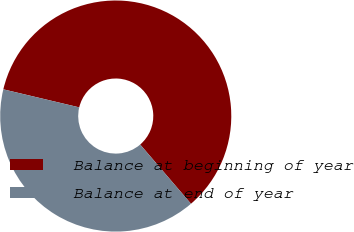Convert chart to OTSL. <chart><loc_0><loc_0><loc_500><loc_500><pie_chart><fcel>Balance at beginning of year<fcel>Balance at end of year<nl><fcel>60.0%<fcel>40.0%<nl></chart> 